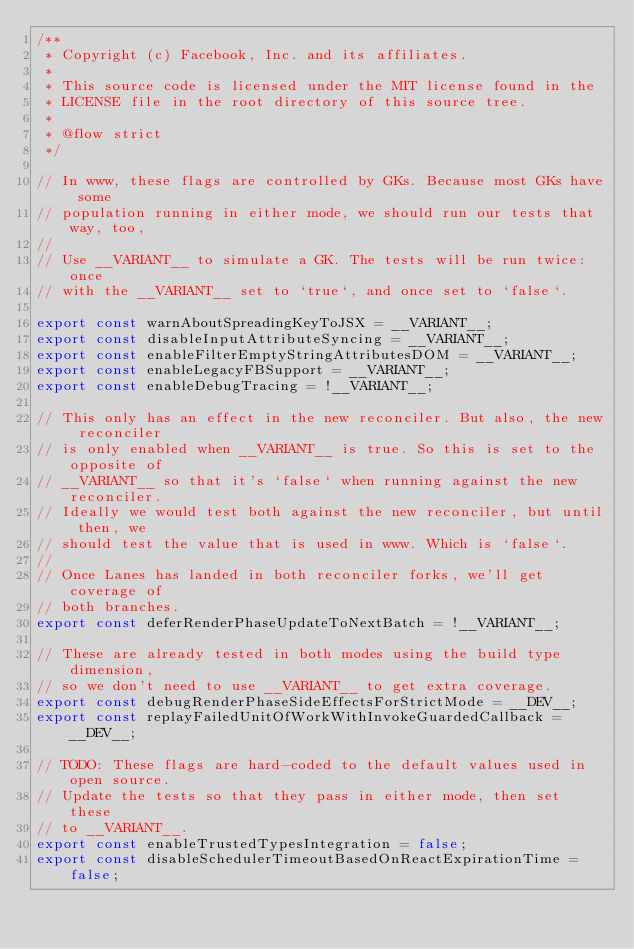Convert code to text. <code><loc_0><loc_0><loc_500><loc_500><_JavaScript_>/**
 * Copyright (c) Facebook, Inc. and its affiliates.
 *
 * This source code is licensed under the MIT license found in the
 * LICENSE file in the root directory of this source tree.
 *
 * @flow strict
 */

// In www, these flags are controlled by GKs. Because most GKs have some
// population running in either mode, we should run our tests that way, too,
//
// Use __VARIANT__ to simulate a GK. The tests will be run twice: once
// with the __VARIANT__ set to `true`, and once set to `false`.

export const warnAboutSpreadingKeyToJSX = __VARIANT__;
export const disableInputAttributeSyncing = __VARIANT__;
export const enableFilterEmptyStringAttributesDOM = __VARIANT__;
export const enableLegacyFBSupport = __VARIANT__;
export const enableDebugTracing = !__VARIANT__;

// This only has an effect in the new reconciler. But also, the new reconciler
// is only enabled when __VARIANT__ is true. So this is set to the opposite of
// __VARIANT__ so that it's `false` when running against the new reconciler.
// Ideally we would test both against the new reconciler, but until then, we
// should test the value that is used in www. Which is `false`.
//
// Once Lanes has landed in both reconciler forks, we'll get coverage of
// both branches.
export const deferRenderPhaseUpdateToNextBatch = !__VARIANT__;

// These are already tested in both modes using the build type dimension,
// so we don't need to use __VARIANT__ to get extra coverage.
export const debugRenderPhaseSideEffectsForStrictMode = __DEV__;
export const replayFailedUnitOfWorkWithInvokeGuardedCallback = __DEV__;

// TODO: These flags are hard-coded to the default values used in open source.
// Update the tests so that they pass in either mode, then set these
// to __VARIANT__.
export const enableTrustedTypesIntegration = false;
export const disableSchedulerTimeoutBasedOnReactExpirationTime = false;
</code> 